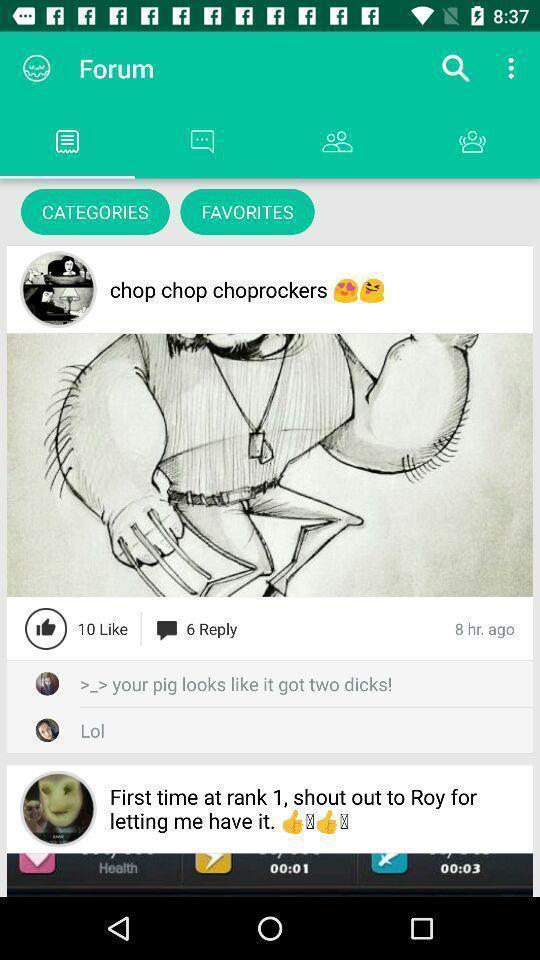What is the overall content of this screenshot? Search bar to search for the category of an item. 